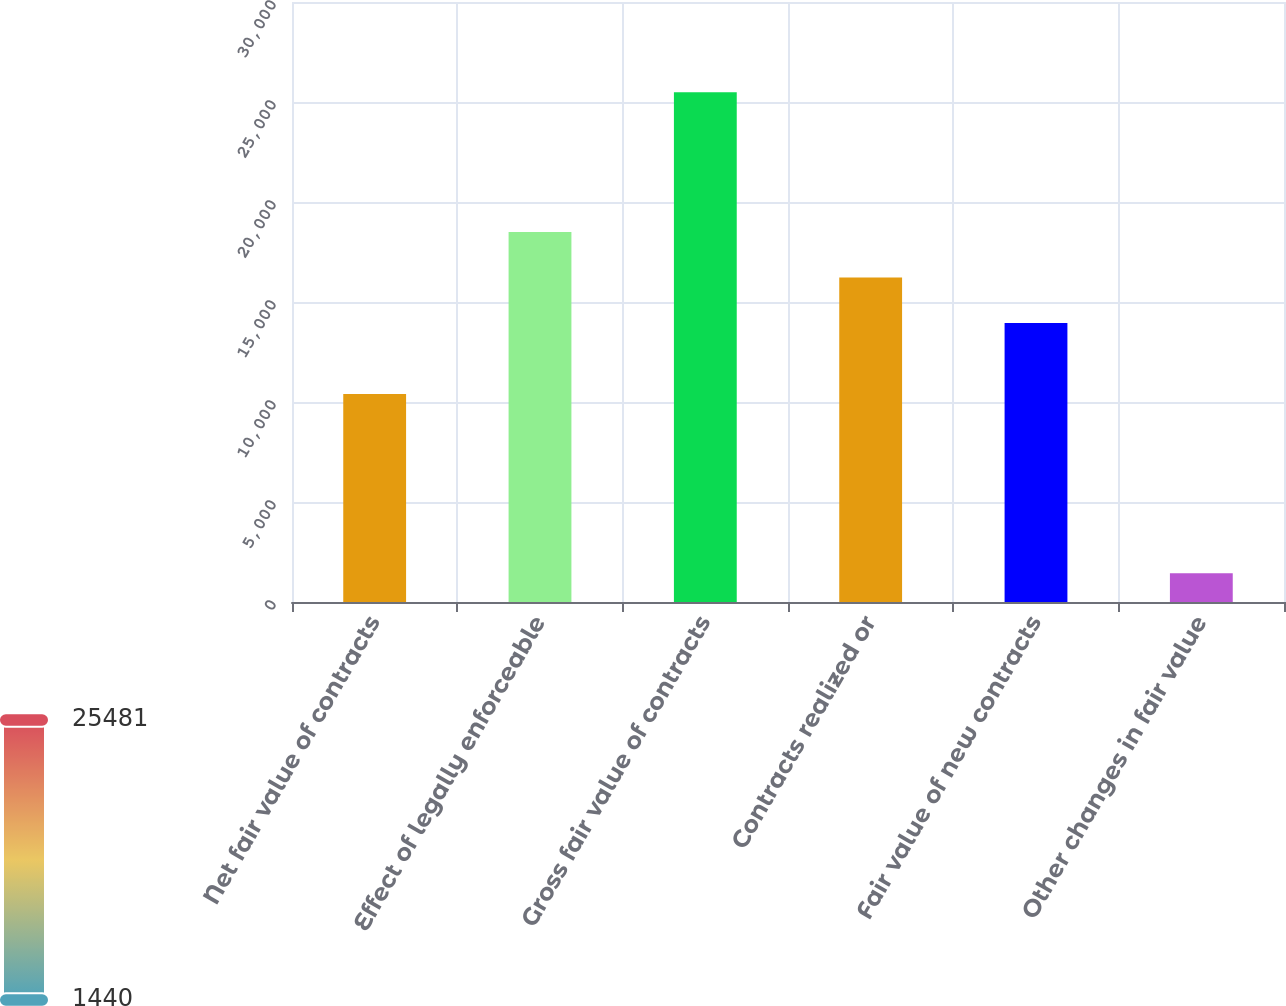Convert chart. <chart><loc_0><loc_0><loc_500><loc_500><bar_chart><fcel>Net fair value of contracts<fcel>Effect of legally enforceable<fcel>Gross fair value of contracts<fcel>Contracts realized or<fcel>Fair value of new contracts<fcel>Other changes in fair value<nl><fcel>10399.3<fcel>18496.6<fcel>25481.3<fcel>16225.3<fcel>13954<fcel>1440<nl></chart> 